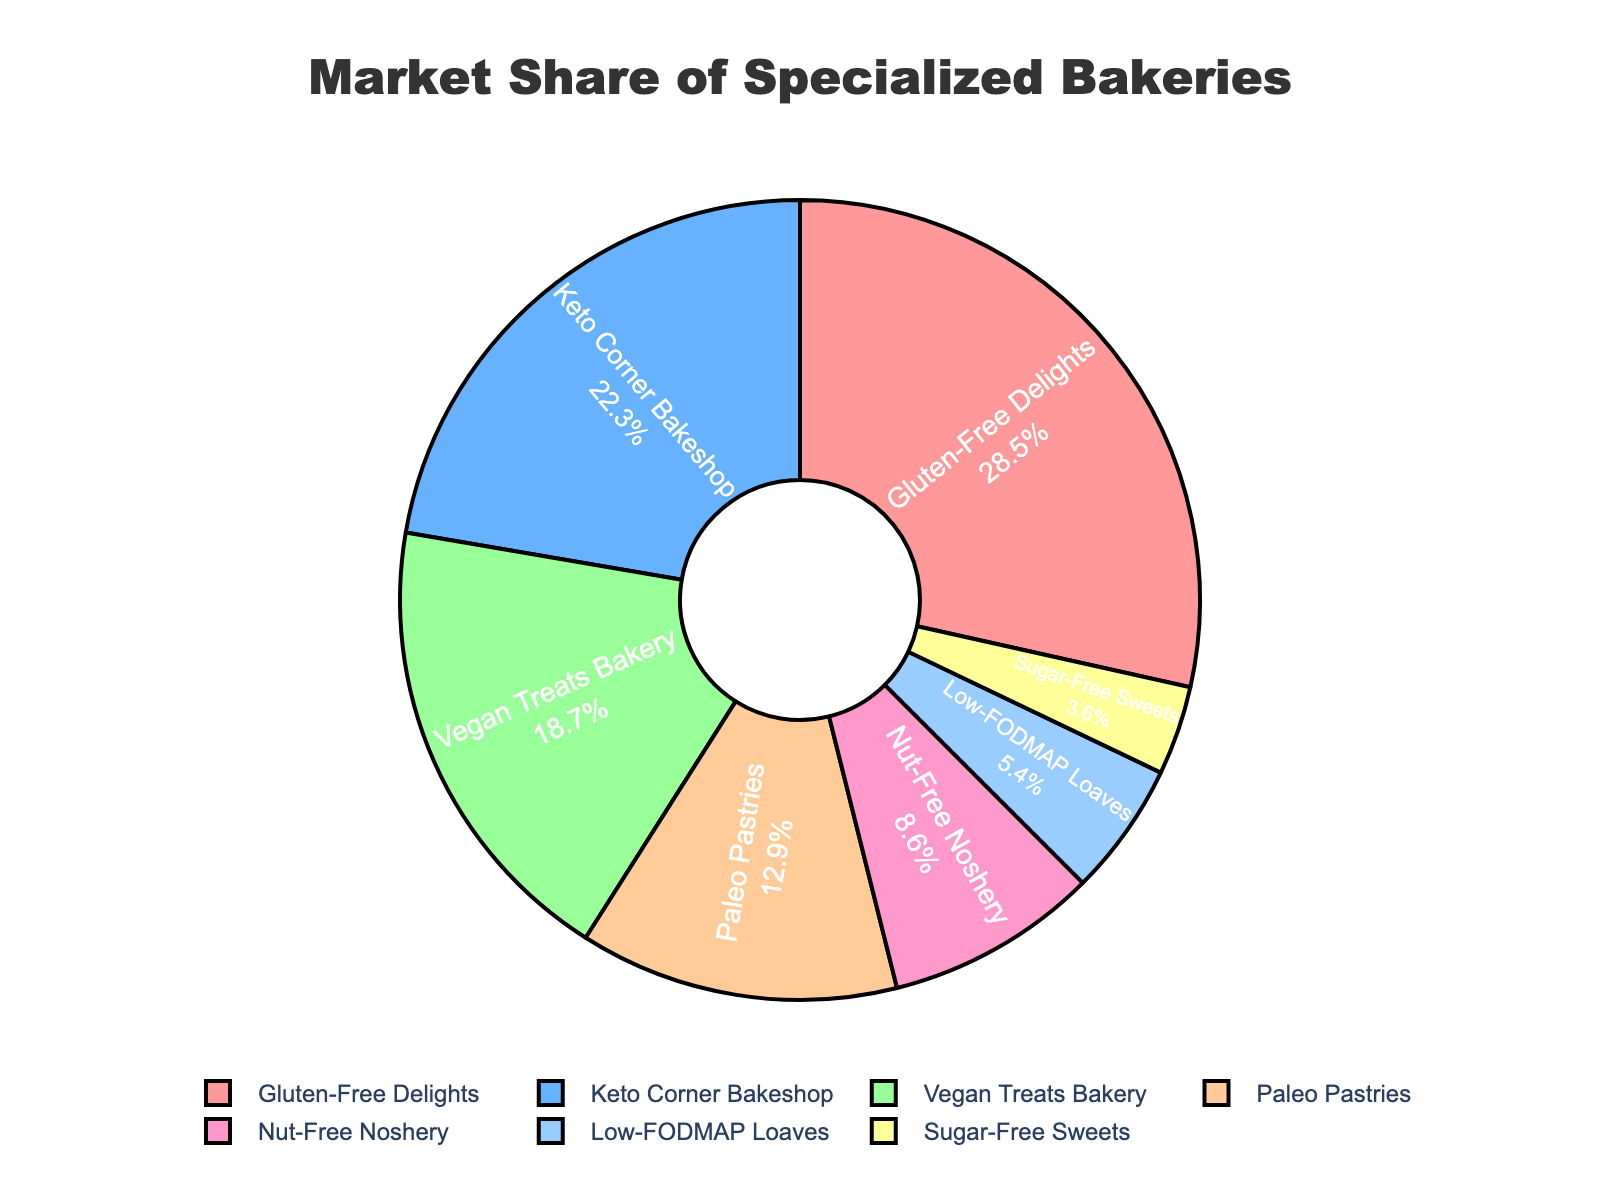Which bakery has the largest market share? Look at the pie chart and identify the segment with the largest value. Gluten-Free Delights has the largest market share at 28.5%.
Answer: Gluten-Free Delights Which bakery has the smallest market share? Examine the pie chart and find the segment with the smallest value. Sugar-Free Sweets has the smallest market share at 3.6%.
Answer: Sugar-Free Sweets What is the combined market share of Gluten-Free Delights and Keto Corner Bakeshop? Add the market share percentages of Gluten-Free Delights (28.5%) and Keto Corner Bakeshop (22.3%). The combined market share is 28.5 + 22.3 = 50.8%.
Answer: 50.8% How much greater is the market share of Vegan Treats Bakery compared to Nut-Free Noshery? Subtract the market share percentage of Nut-Free Noshery (8.6%) from Vegan Treats Bakery (18.7%). The difference is 18.7 - 8.6 = 10.1%.
Answer: 10.1% Which bakeries together account for more than half of the market share? Add the market share percentages of bakeries until the sum exceeds 50%. Gluten-Free Delights (28.5%) + Keto Corner Bakeshop (22.3%) = 50.8%. These two bakeries account for more than half of the market share.
Answer: Gluten-Free Delights and Keto Corner Bakeshop Which bakery has the green-colored segment? The color green is associated with the Vegan Treats Bakery segment in the pie chart.
Answer: Vegan Treats Bakery What is the sum of market shares of Low-FODMAP Loaves and Sugar-Free Sweets? Add the market share percentages of Low-FODMAP Loaves (5.4%) and Sugar-Free Sweets (3.6%). The sum is 5.4 + 3.6 = 9.0%.
Answer: 9.0% Which bakery has a market share between 5% and 10%? Identify the bakery segments with market shares within the range of 5% to 10%. Nut-Free Noshery has a market share of 8.6%, falling within this range.
Answer: Nut-Free Noshery What is the average market share of Paleo Pastries, Nut-Free Noshery, and Low-FODMAP Loaves? Add the market share percentages of Paleo Pastries (12.9%), Nut-Free Noshery (8.6%), and Low-FODMAP Loaves (5.4%), then divide by 3. The average is (12.9 + 8.6 + 5.4) / 3 = 8.97%.
Answer: 8.97% Which bakeries have market shares combined to less than Paleo Pastries? Calculate the combined market shares of the three smallest bakeries: Nut-Free Noshery (8.6%) + Low-FODMAP Loaves (5.4%) + Sugar-Free Sweets (3.6%) = 17.6%, which is greater than Paleo Pastries' 12.9%. Hence, no combination of these bakeries has a combined market share less than Paleo Pastries.
Answer: None 